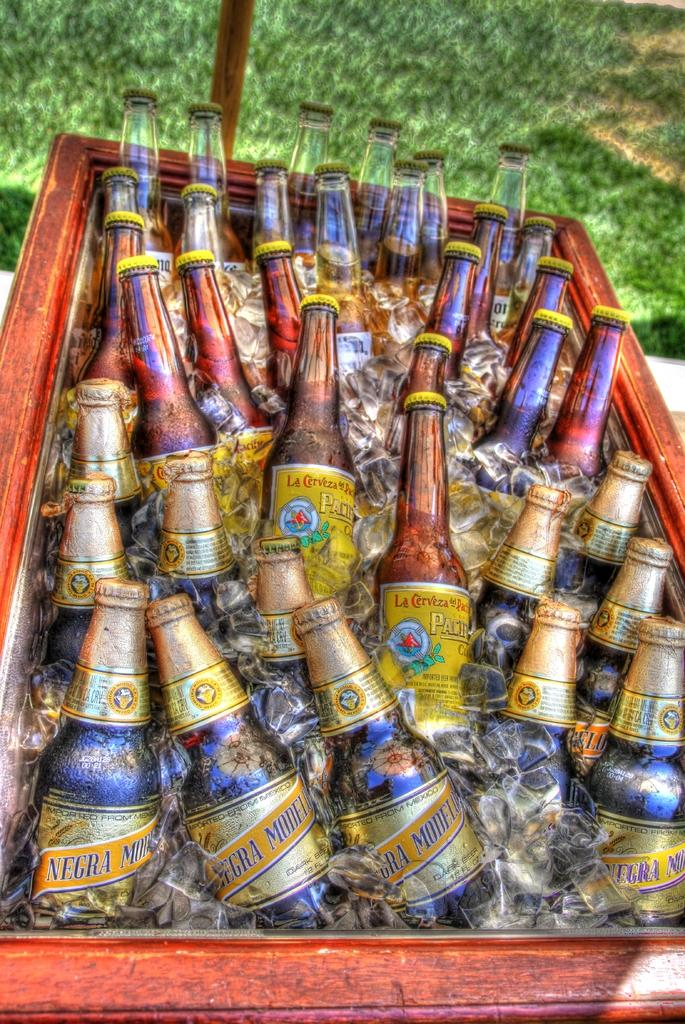<image>
Provide a brief description of the given image. Icebox full of  cold Negra Modelo, Pacifico and Corona beers. 